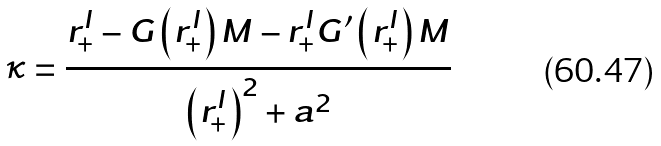Convert formula to latex. <formula><loc_0><loc_0><loc_500><loc_500>\kappa = \frac { r _ { + } ^ { I } - G \left ( r _ { + } ^ { I } \right ) M - r _ { + } ^ { I } G ^ { \prime } \left ( r _ { + } ^ { I } \right ) M } { \left ( r _ { + } ^ { I } \right ) ^ { 2 } + a ^ { 2 } }</formula> 